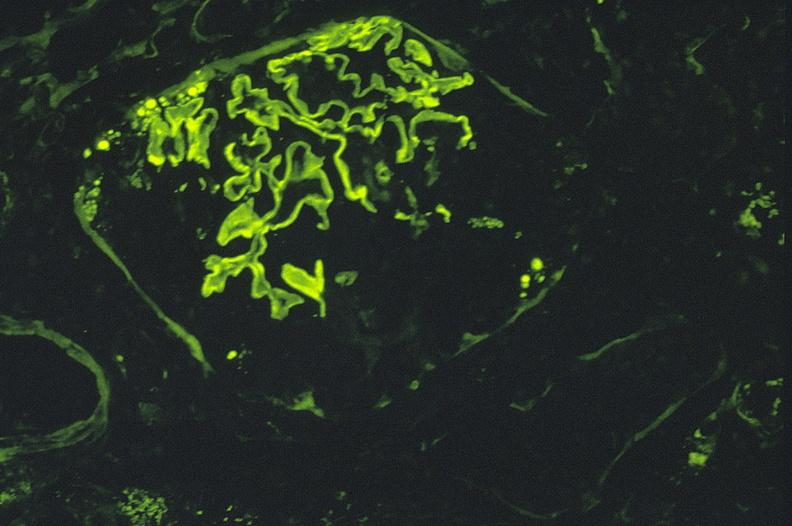does this image show antiglomerlar basement membrane, kappa?
Answer the question using a single word or phrase. Yes 